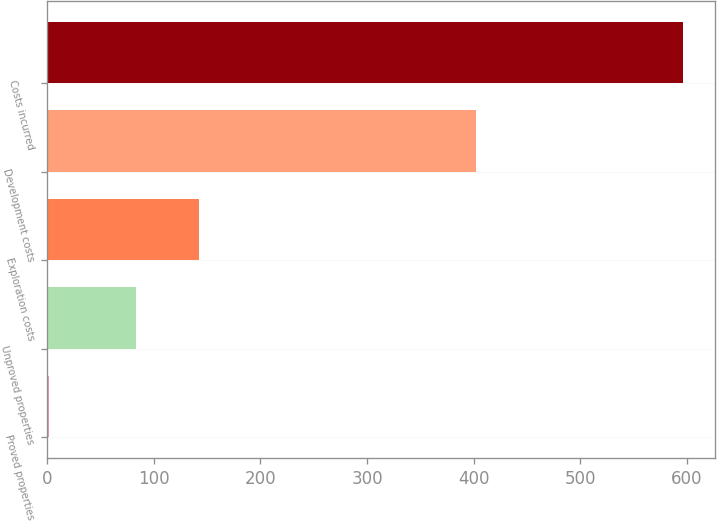Convert chart to OTSL. <chart><loc_0><loc_0><loc_500><loc_500><bar_chart><fcel>Proved properties<fcel>Unproved properties<fcel>Exploration costs<fcel>Development costs<fcel>Costs incurred<nl><fcel>2<fcel>83<fcel>142.4<fcel>402<fcel>596<nl></chart> 